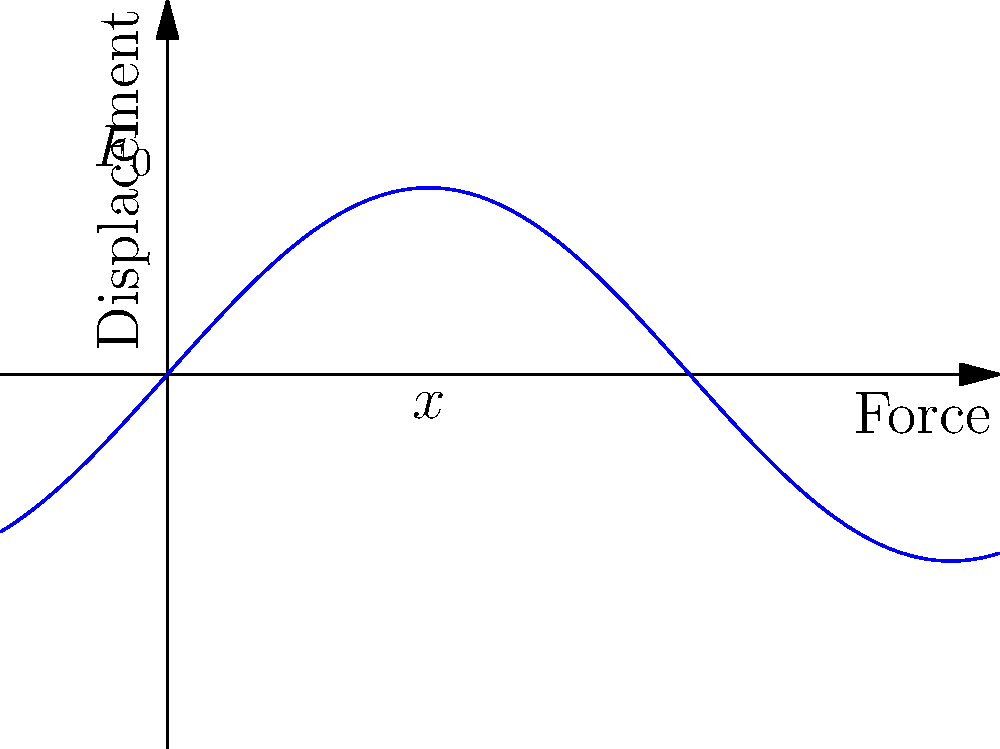In the context of a spring-mass-damper system under harmonic excitation, how would you visually represent the phase shift between the applied force and the resulting displacement in a force-displacement curve? Consider how this representation might be used in a visual narrative about the interplay between external forces and system response. To understand the visual representation of a force-displacement curve for a spring-mass-damper system under harmonic excitation, let's break it down step-by-step:

1. The system is described by the equation:
   $$m\ddot{x} + c\dot{x} + kx = F_0 \sin(\omega t)$$
   where $m$ is mass, $c$ is damping coefficient, $k$ is spring constant, $F_0$ is force amplitude, and $\omega$ is angular frequency.

2. The steady-state solution for displacement is:
   $$x(t) = X \sin(\omega t - \phi)$$
   where $X$ is displacement amplitude and $\phi$ is phase shift.

3. The force-displacement curve is a plot of $F(t)$ vs $x(t)$, which forms an ellipse due to the phase shift.

4. The ellipse's shape depends on the phase shift:
   - If $\phi = 0$ or $\pi$, it collapses to a straight line.
   - If $\phi = \pi/2$, it becomes a circle.
   - For other values, it's an ellipse.

5. The area inside the ellipse represents energy dissipated per cycle due to damping.

6. In the context of visual storytelling:
   - The ellipse's shape could symbolize the "character arc" of the system's response.
   - The phase shift could represent a delay or anticipation in the narrative.
   - The energy dissipation could be a metaphor for the transformation or evolution of the story elements.

Visually, the curve starts at the origin, moves clockwise, and completes one cycle for each period of oscillation.
Answer: Elliptical curve, clockwise direction, area representing energy dissipation 